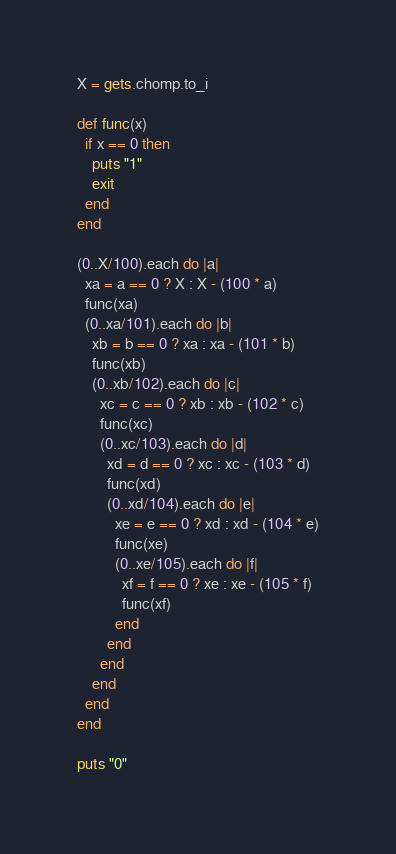Convert code to text. <code><loc_0><loc_0><loc_500><loc_500><_Ruby_>X = gets.chomp.to_i

def func(x)
  if x == 0 then
    puts "1"
    exit
  end
end

(0..X/100).each do |a|
  xa = a == 0 ? X : X - (100 * a)
  func(xa)
  (0..xa/101).each do |b|
    xb = b == 0 ? xa : xa - (101 * b)
    func(xb)
    (0..xb/102).each do |c|
      xc = c == 0 ? xb : xb - (102 * c)
      func(xc)
      (0..xc/103).each do |d|
        xd = d == 0 ? xc : xc - (103 * d)
        func(xd)
        (0..xd/104).each do |e|
          xe = e == 0 ? xd : xd - (104 * e)
          func(xe)
          (0..xe/105).each do |f|
            xf = f == 0 ? xe : xe - (105 * f)
            func(xf)
          end
        end
      end
    end
  end
end

puts "0"</code> 